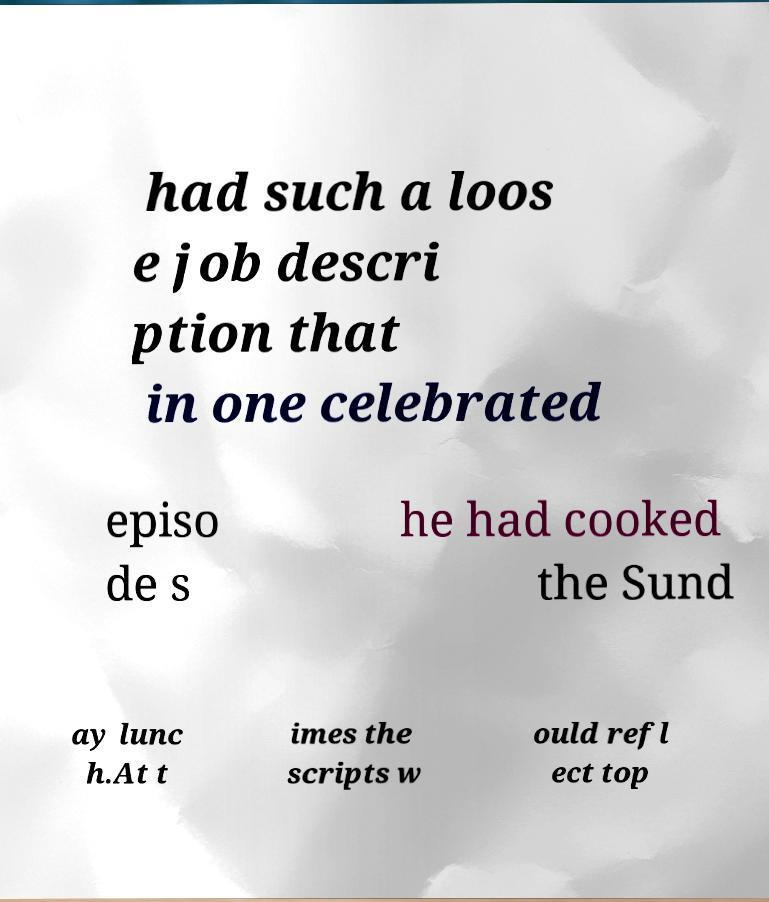Could you assist in decoding the text presented in this image and type it out clearly? had such a loos e job descri ption that in one celebrated episo de s he had cooked the Sund ay lunc h.At t imes the scripts w ould refl ect top 